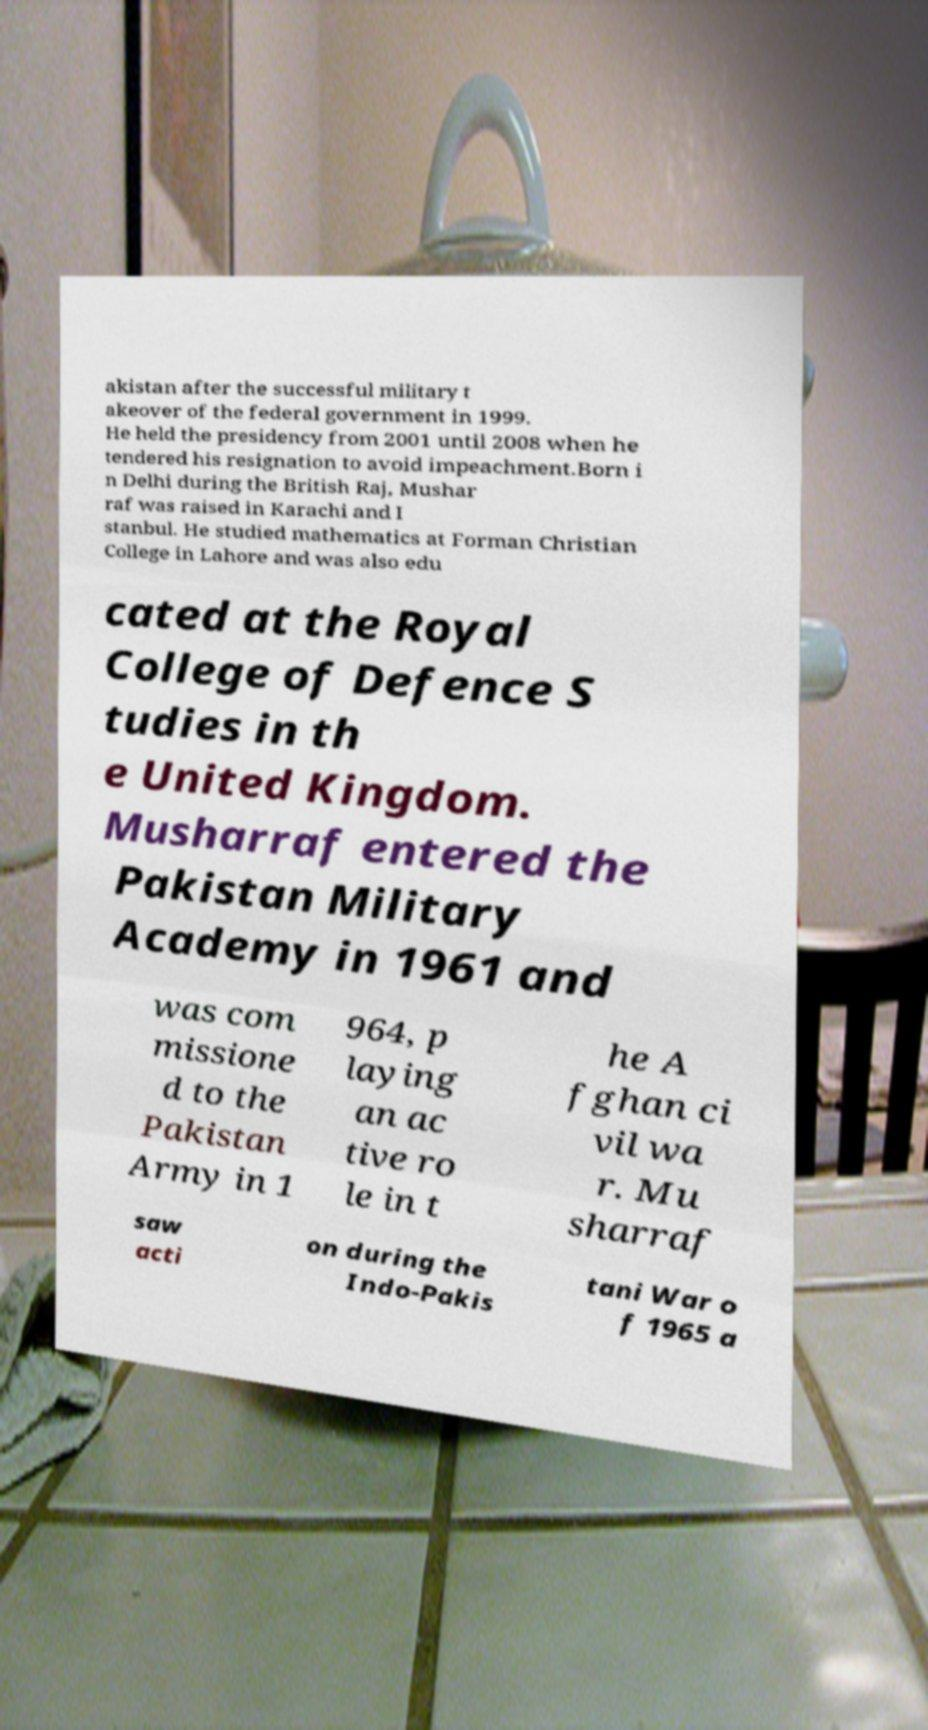Please identify and transcribe the text found in this image. akistan after the successful military t akeover of the federal government in 1999. He held the presidency from 2001 until 2008 when he tendered his resignation to avoid impeachment.Born i n Delhi during the British Raj, Mushar raf was raised in Karachi and I stanbul. He studied mathematics at Forman Christian College in Lahore and was also edu cated at the Royal College of Defence S tudies in th e United Kingdom. Musharraf entered the Pakistan Military Academy in 1961 and was com missione d to the Pakistan Army in 1 964, p laying an ac tive ro le in t he A fghan ci vil wa r. Mu sharraf saw acti on during the Indo-Pakis tani War o f 1965 a 